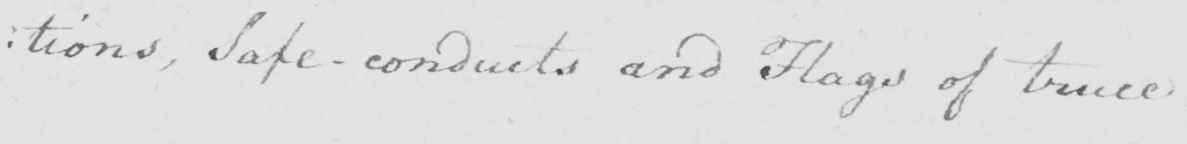Can you tell me what this handwritten text says? : tions , Safe-conducts and Flags of truce . 